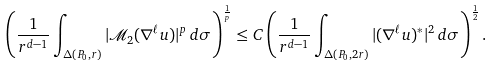Convert formula to latex. <formula><loc_0><loc_0><loc_500><loc_500>\left ( \frac { 1 } { r ^ { d - 1 } } \int _ { \Delta ( P _ { 0 } , r ) } | \mathcal { M } _ { 2 } ( \nabla ^ { \ell } u ) | ^ { p } \, d \sigma \right ) ^ { \frac { 1 } { p } } \leq C \left ( \frac { 1 } { r ^ { d - 1 } } \int _ { \Delta ( P _ { 0 } , 2 r ) } | ( \nabla ^ { \ell } u ) ^ { * } | ^ { 2 } \, d \sigma \right ) ^ { \frac { 1 } { 2 } } .</formula> 